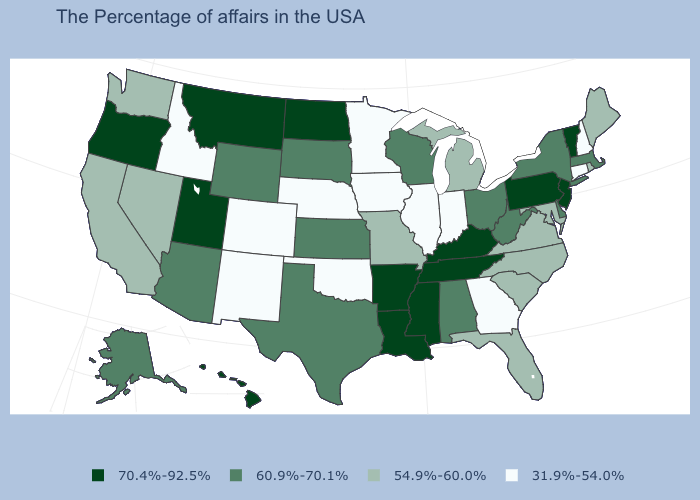What is the value of California?
Short answer required. 54.9%-60.0%. What is the lowest value in the USA?
Answer briefly. 31.9%-54.0%. Which states have the highest value in the USA?
Write a very short answer. Vermont, New Jersey, Pennsylvania, Kentucky, Tennessee, Mississippi, Louisiana, Arkansas, North Dakota, Utah, Montana, Oregon, Hawaii. What is the value of Montana?
Keep it brief. 70.4%-92.5%. Name the states that have a value in the range 60.9%-70.1%?
Quick response, please. Massachusetts, New York, Delaware, West Virginia, Ohio, Alabama, Wisconsin, Kansas, Texas, South Dakota, Wyoming, Arizona, Alaska. Name the states that have a value in the range 70.4%-92.5%?
Be succinct. Vermont, New Jersey, Pennsylvania, Kentucky, Tennessee, Mississippi, Louisiana, Arkansas, North Dakota, Utah, Montana, Oregon, Hawaii. Name the states that have a value in the range 31.9%-54.0%?
Be succinct. New Hampshire, Connecticut, Georgia, Indiana, Illinois, Minnesota, Iowa, Nebraska, Oklahoma, Colorado, New Mexico, Idaho. What is the highest value in the Northeast ?
Give a very brief answer. 70.4%-92.5%. What is the highest value in the Northeast ?
Be succinct. 70.4%-92.5%. Name the states that have a value in the range 31.9%-54.0%?
Give a very brief answer. New Hampshire, Connecticut, Georgia, Indiana, Illinois, Minnesota, Iowa, Nebraska, Oklahoma, Colorado, New Mexico, Idaho. Does Indiana have a lower value than Illinois?
Write a very short answer. No. Which states hav the highest value in the Northeast?
Quick response, please. Vermont, New Jersey, Pennsylvania. Among the states that border Wyoming , does Nebraska have the highest value?
Write a very short answer. No. How many symbols are there in the legend?
Keep it brief. 4. Which states hav the highest value in the MidWest?
Concise answer only. North Dakota. 